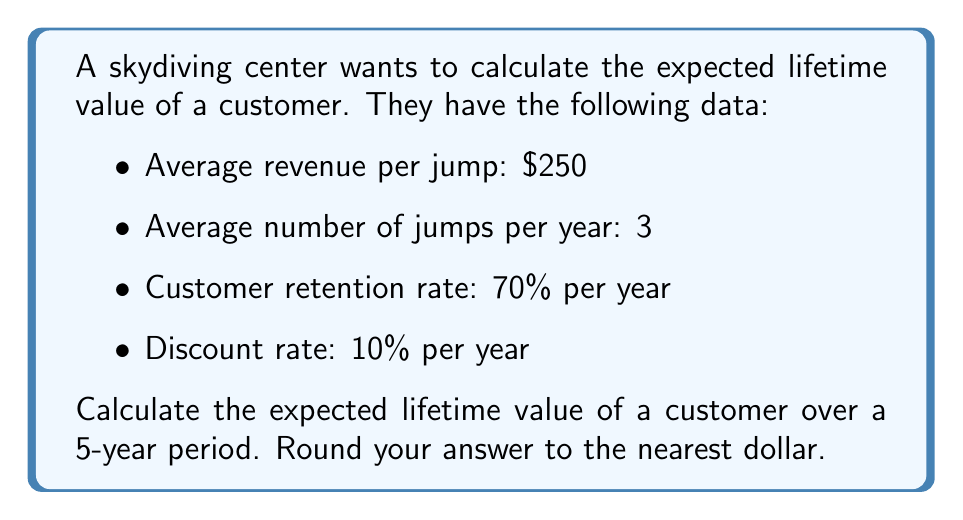Can you answer this question? To calculate the expected lifetime value of a customer, we'll use the following steps:

1. Calculate the annual revenue per customer:
   Annual revenue = Average revenue per jump × Average number of jumps per year
   $250 × 3 = $750

2. Use the customer retention rate to calculate the probability of a customer returning each year:
   Year 1: 100% (initial year)
   Year 2: 70%
   Year 3: 70% × 70% = 49%
   Year 4: 70% × 70% × 70% = 34.3%
   Year 5: 70% × 70% × 70% × 70% = 24.01%

3. Calculate the present value of each year's expected revenue using the discount rate:
   Year 1: $750 ÷ (1 + 0.10)^1 = $681.82
   Year 2: $750 × 0.70 ÷ (1 + 0.10)^2 = $433.88
   Year 3: $750 × 0.49 ÷ (1 + 0.10)^3 = $275.92
   Year 4: $750 × 0.343 ÷ (1 + 0.10)^4 = $175.50
   Year 5: $750 × 0.2401 ÷ (1 + 0.10)^5 = $111.56

4. Sum up the present values to get the total expected lifetime value:

   $$ \text{Lifetime Value} = \sum_{t=1}^{5} \frac{750 \times 0.7^{t-1}}{(1 + 0.10)^t} $$

   $681.82 + $433.88 + $275.92 + $175.50 + $111.56 = $1,678.68

5. Round to the nearest dollar:
   $1,679
Answer: $1,679 